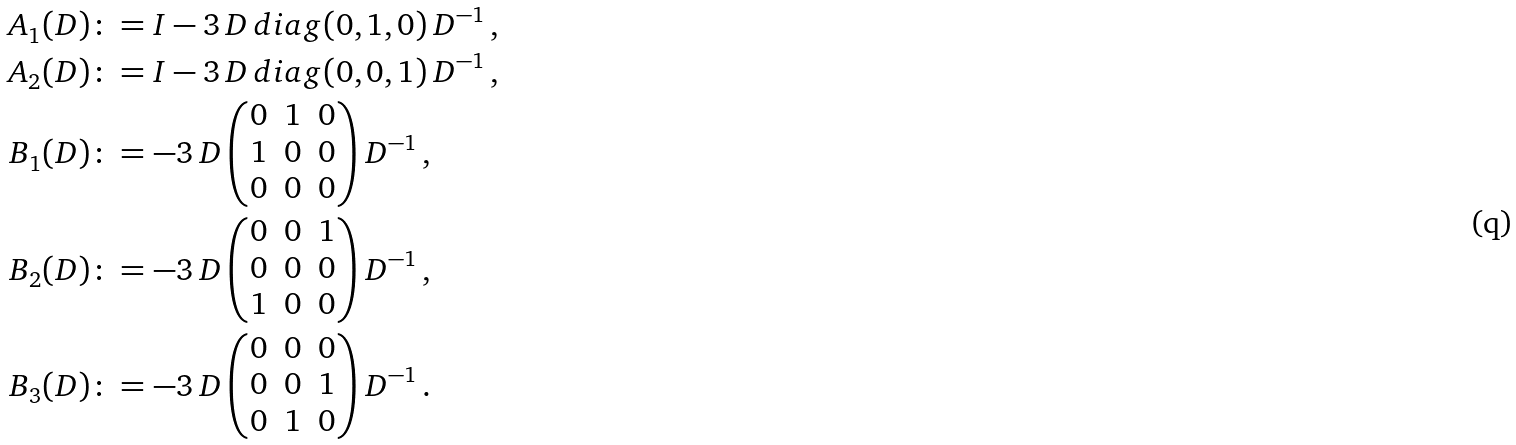Convert formula to latex. <formula><loc_0><loc_0><loc_500><loc_500>A _ { 1 } ( D ) & \colon = I - 3 \, D \, d i a g ( 0 , 1 , 0 ) \, D ^ { - 1 } \, , \\ A _ { 2 } ( D ) & \colon = I - 3 \, D \, d i a g ( 0 , 0 , 1 ) \, D ^ { - 1 } \, , \\ B _ { 1 } ( D ) & \colon = - 3 \, D \, { \begin{pmatrix} 0 & 1 & 0 \\ 1 & 0 & 0 \\ 0 & 0 & 0 \end{pmatrix} } \, D ^ { - 1 } \, , \\ B _ { 2 } ( D ) & \colon = - 3 \, D \, { \begin{pmatrix} 0 & 0 & 1 \\ 0 & 0 & 0 \\ 1 & 0 & 0 \end{pmatrix} } \, D ^ { - 1 } \, , \\ B _ { 3 } ( D ) & \colon = - 3 \, D \, { \begin{pmatrix} 0 & 0 & 0 \\ 0 & 0 & 1 \\ 0 & 1 & 0 \end{pmatrix} } \, D ^ { - 1 } \, .</formula> 